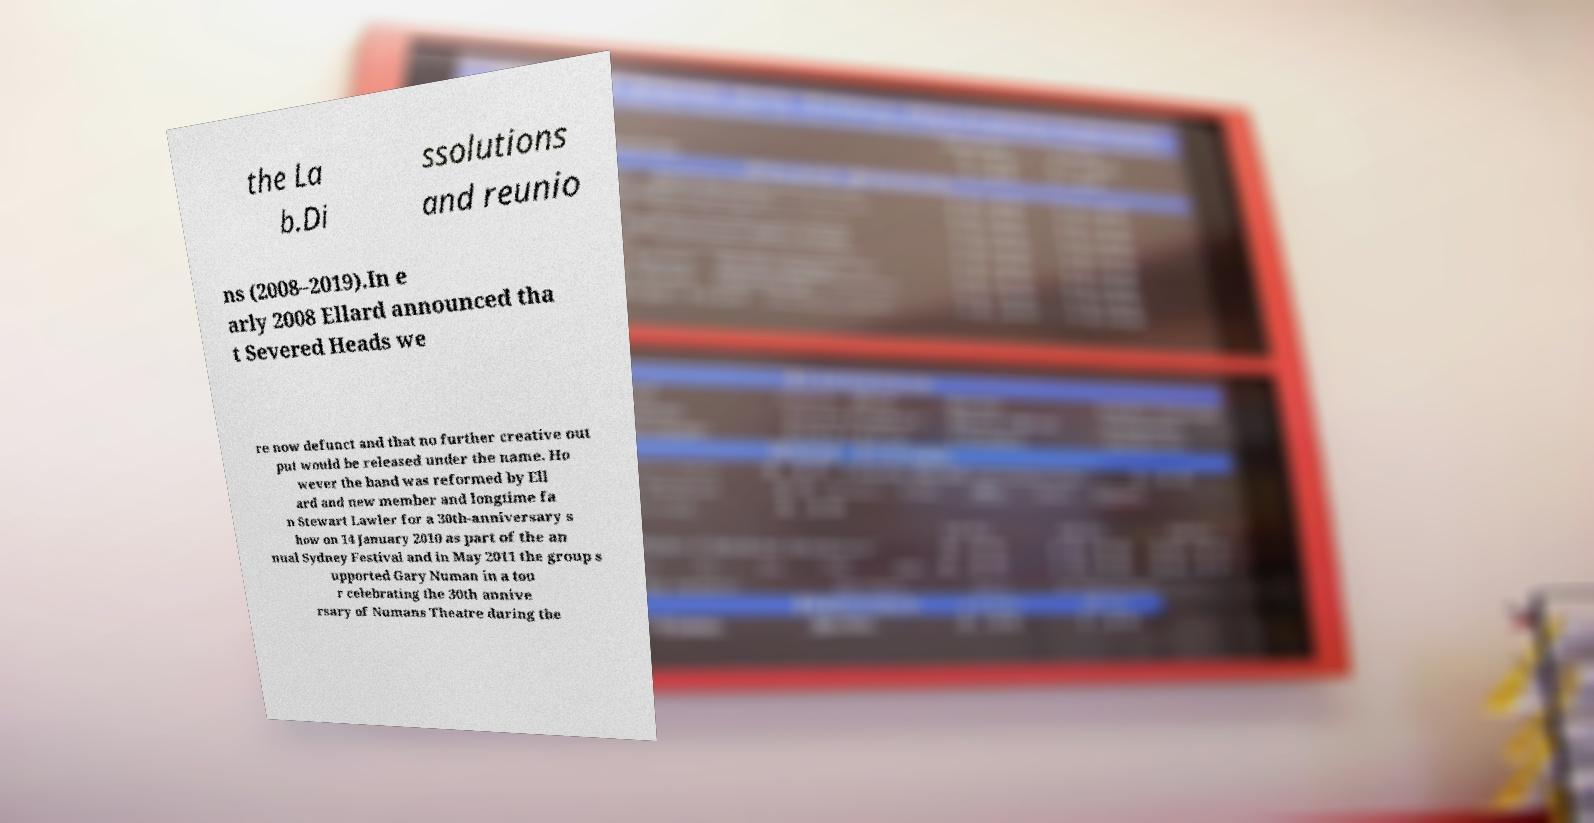Please identify and transcribe the text found in this image. the La b.Di ssolutions and reunio ns (2008–2019).In e arly 2008 Ellard announced tha t Severed Heads we re now defunct and that no further creative out put would be released under the name. Ho wever the band was reformed by Ell ard and new member and longtime fa n Stewart Lawler for a 30th-anniversary s how on 14 January 2010 as part of the an nual Sydney Festival and in May 2011 the group s upported Gary Numan in a tou r celebrating the 30th annive rsary of Numans Theatre during the 